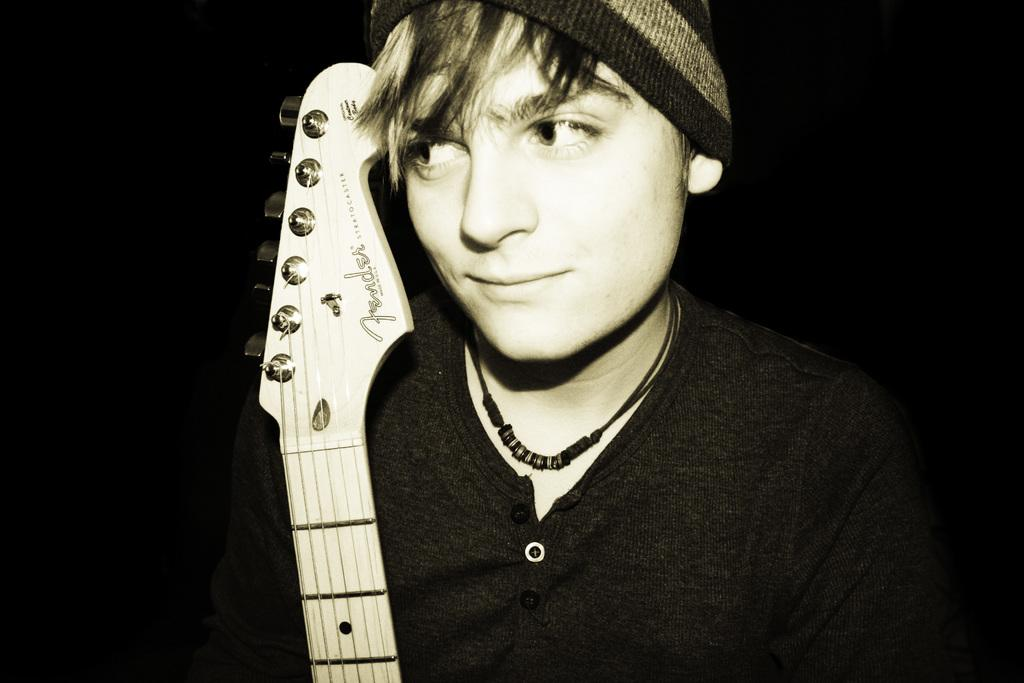What is the color scheme of the image? The image is in black and white. Who is present in the image? There is a man in the image. What is the man wearing? The man is wearing a black t-shirt. What is the man holding in the image? The man is holding a guitar. What type of headwear is the man wearing? The man is wearing a hat. What is the background color behind the man? The background of the man is black. How much wealth does the man in the image possess? There is no information about the man's wealth in the image. What is the size of the lamp in the image? There is no lamp present in the image. 